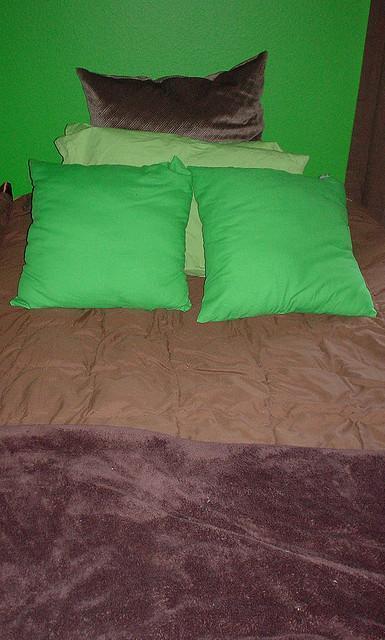How many green pillows?
Give a very brief answer. 3. How many beds are in the picture?
Give a very brief answer. 1. 